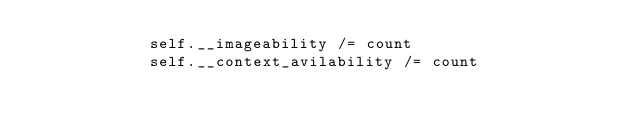Convert code to text. <code><loc_0><loc_0><loc_500><loc_500><_Python_>            self.__imageability /= count
            self.__context_avilability /= count</code> 